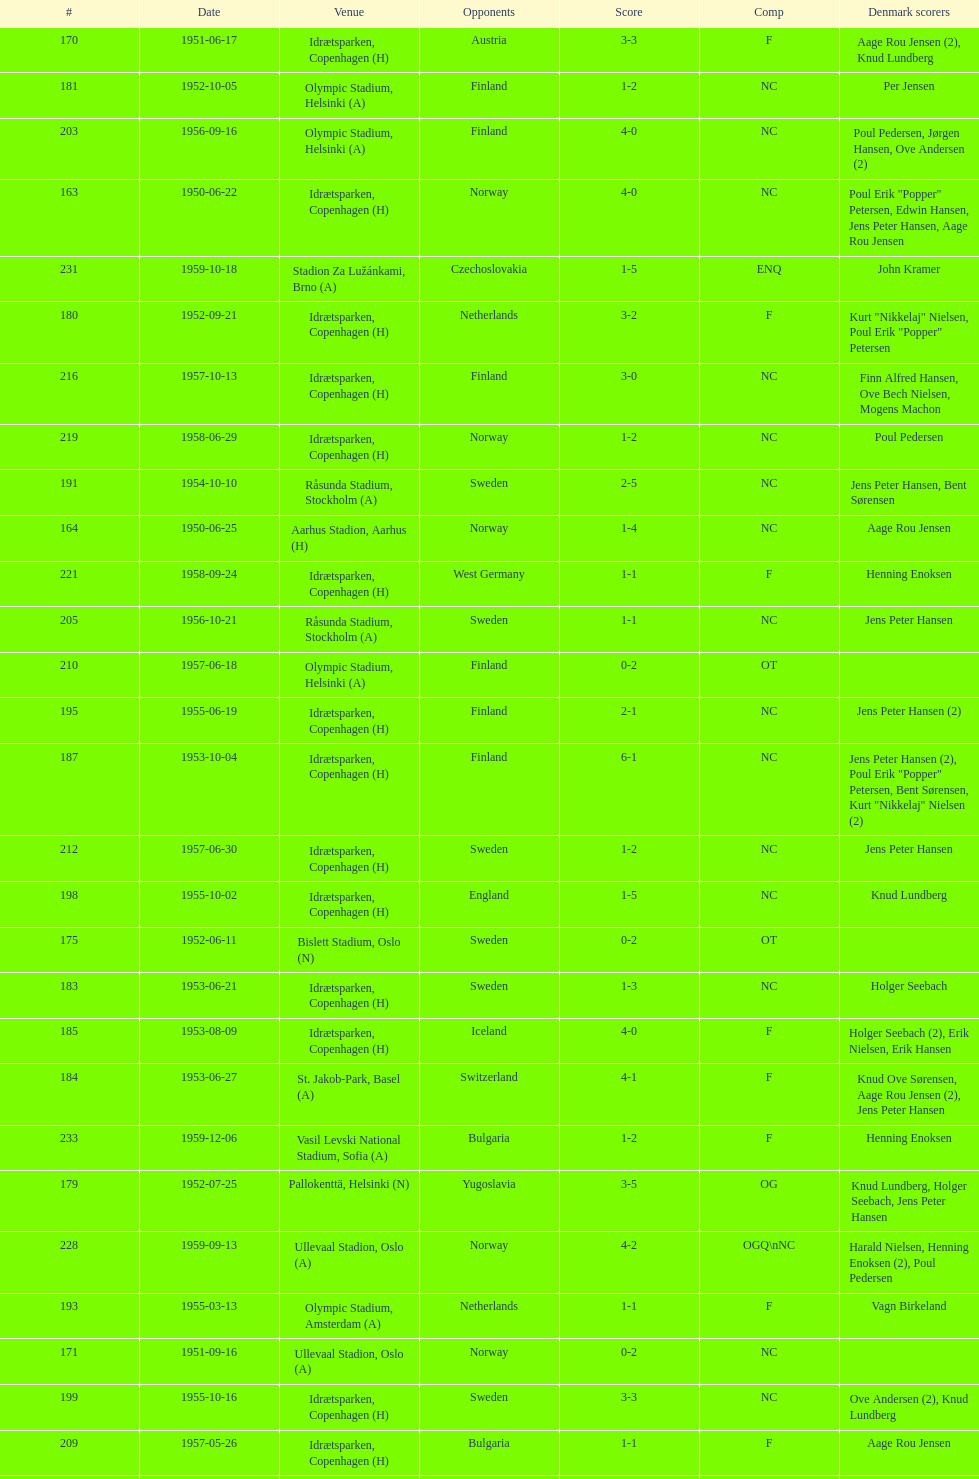How many times was poland the opponent? 2. 